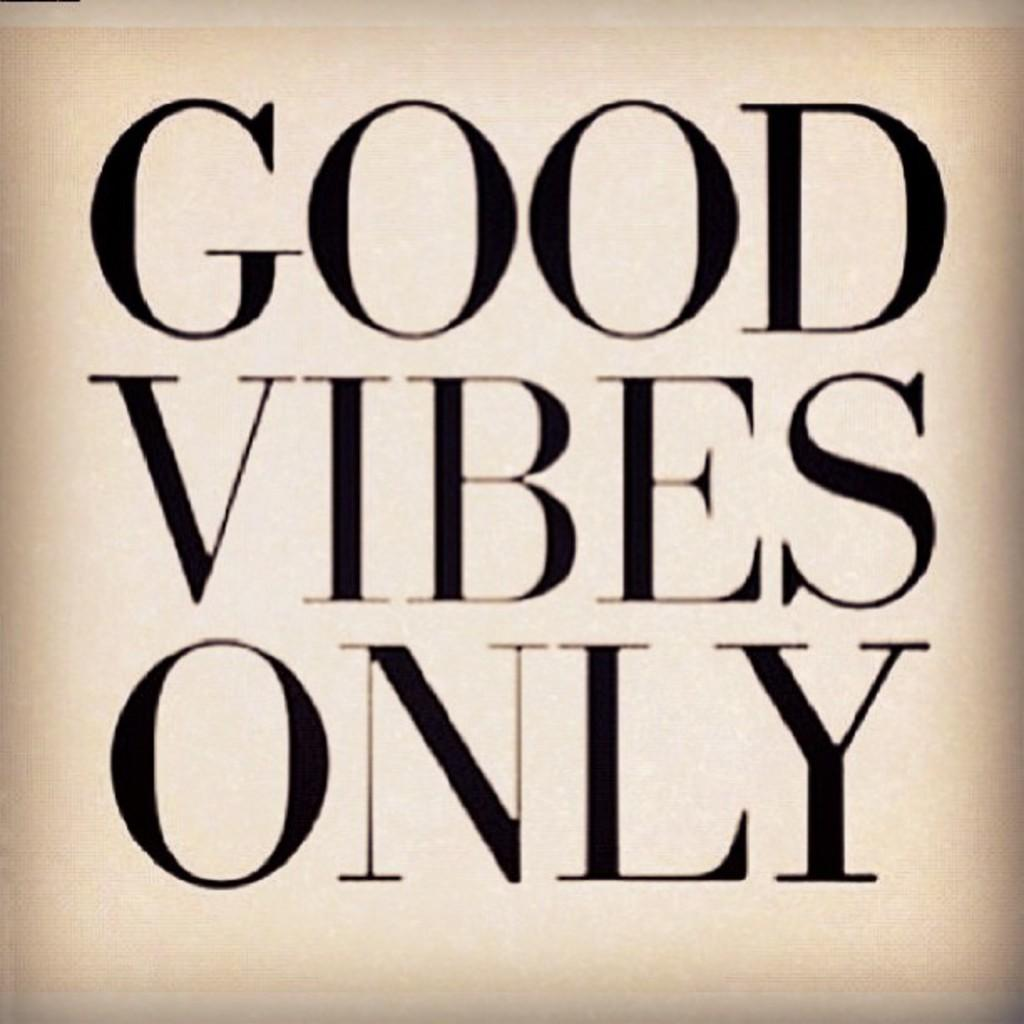<image>
Write a terse but informative summary of the picture. a poster that says 'good vibes only' on it 